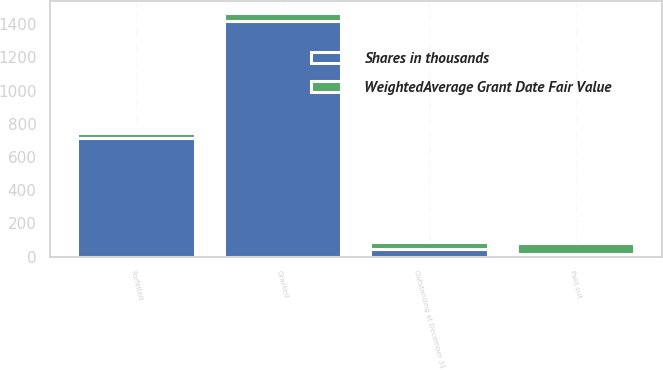Convert chart to OTSL. <chart><loc_0><loc_0><loc_500><loc_500><stacked_bar_chart><ecel><fcel>Outstanding at December 31<fcel>Granted<fcel>Forfeited<fcel>Paid out<nl><fcel>Shares in thousands<fcel>43.89<fcel>1421<fcel>716<fcel>15<nl><fcel>WeightedAverage Grant Date Fair Value<fcel>42.52<fcel>43.33<fcel>25.72<fcel>64.57<nl></chart> 